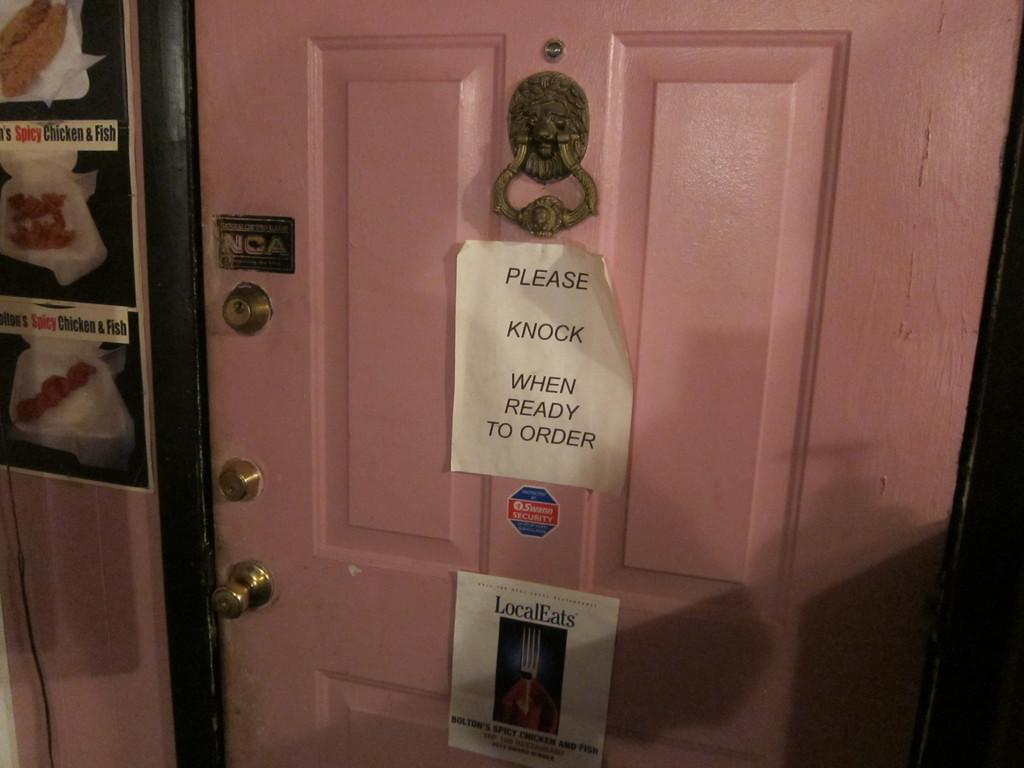<image>
Describe the image concisely. a pink door with a sign saying please knock when ready to order 